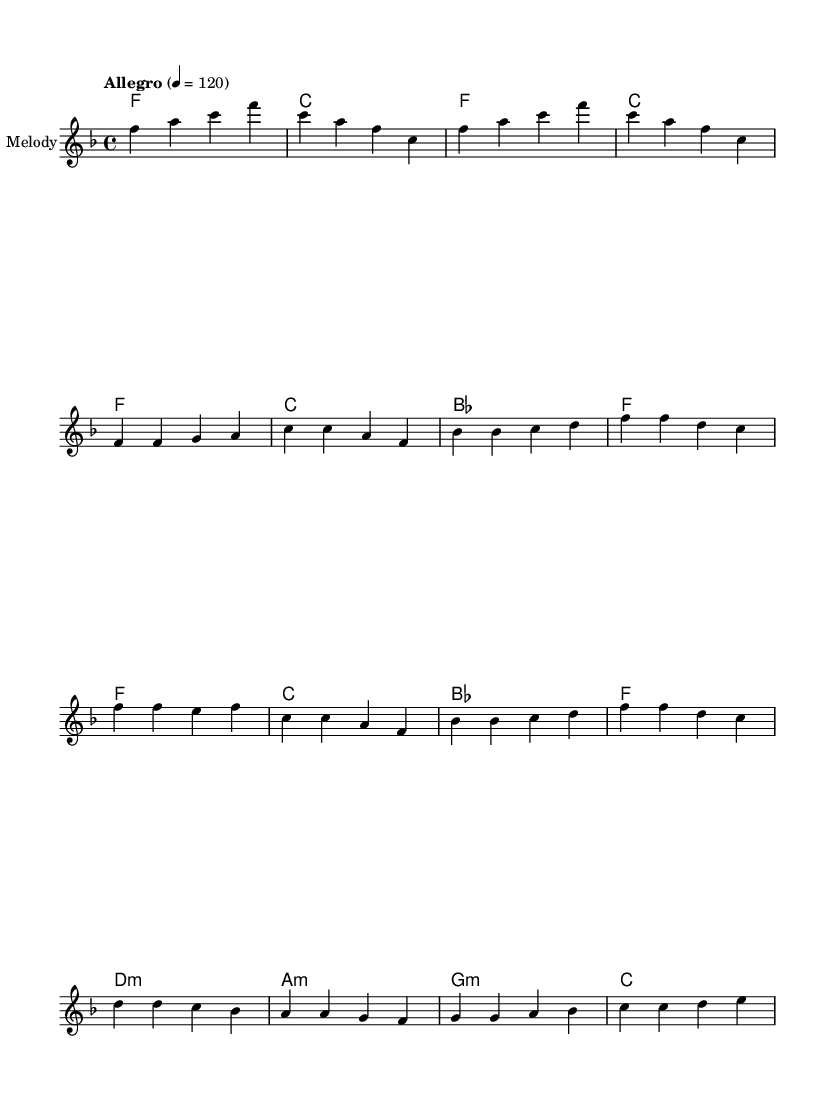What is the key signature of this music? The key signature is F major, as indicated by the presence of one flat (B flat).
Answer: F major What is the time signature of this music? The time signature is 4/4, which is shown at the beginning of the score.
Answer: 4/4 What is the tempo marking indicated in the sheet music? The tempo marking is "Allegro", suggesting a lively and fast tempo. The metronome marking indicates a tempo of 120 beats per minute.
Answer: Allegro How many measures are there in the verse section? The verse section contains 4 measures as indicated by the group of notes under the verse header.
Answer: 4 Which chord is played in the first measure? The first measure shows an F major chord, indicated by the chord symbol "f" above the staff.
Answer: F What is the last chord of the bridge section? The last chord of the bridge section is C major, which is shown at the end of the bridge chord progression.
Answer: C What is the relationship between the chords used in the verse and chorus? Both the verse and the chorus primarily use the same chords: F major, C major, and B flat major, which creates a cohesive sound throughout the piece.
Answer: Same chords 